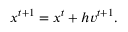<formula> <loc_0><loc_0><loc_500><loc_500>\begin{array} { r } { { x } ^ { t + 1 } = { x } ^ { t } + h { v } ^ { t + 1 } . } \end{array}</formula> 